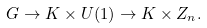Convert formula to latex. <formula><loc_0><loc_0><loc_500><loc_500>G \rightarrow K \times U ( 1 ) \rightarrow K \times Z _ { n } .</formula> 